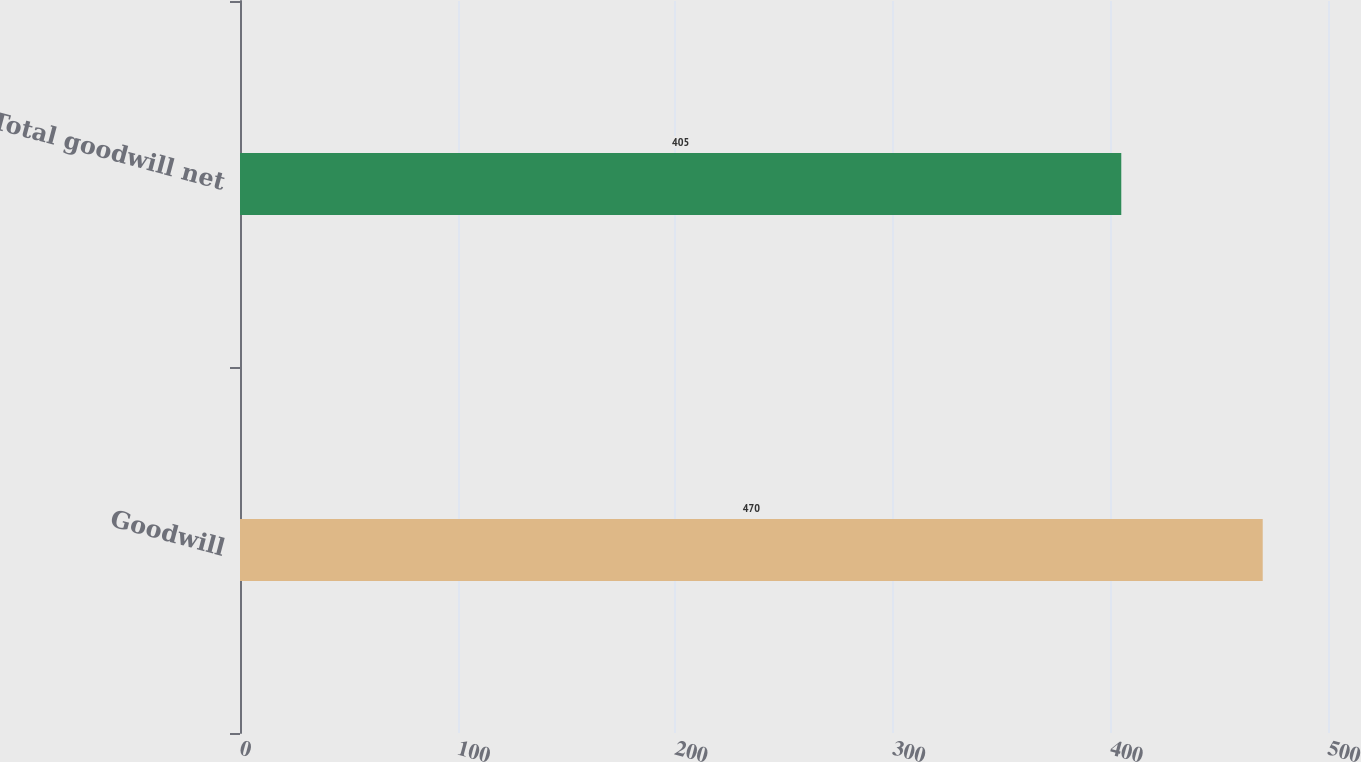<chart> <loc_0><loc_0><loc_500><loc_500><bar_chart><fcel>Goodwill<fcel>Total goodwill net<nl><fcel>470<fcel>405<nl></chart> 